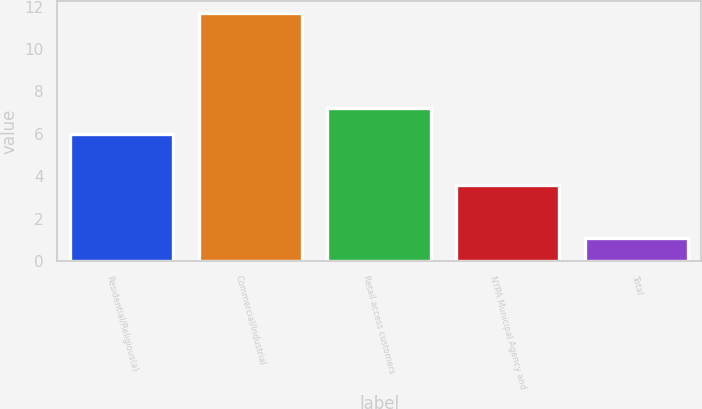Convert chart to OTSL. <chart><loc_0><loc_0><loc_500><loc_500><bar_chart><fcel>Residential/Religious(a)<fcel>Commercial/Industrial<fcel>Retail access customers<fcel>NYPA Municipal Agency and<fcel>Total<nl><fcel>6<fcel>11.7<fcel>7.2<fcel>3.6<fcel>1.1<nl></chart> 